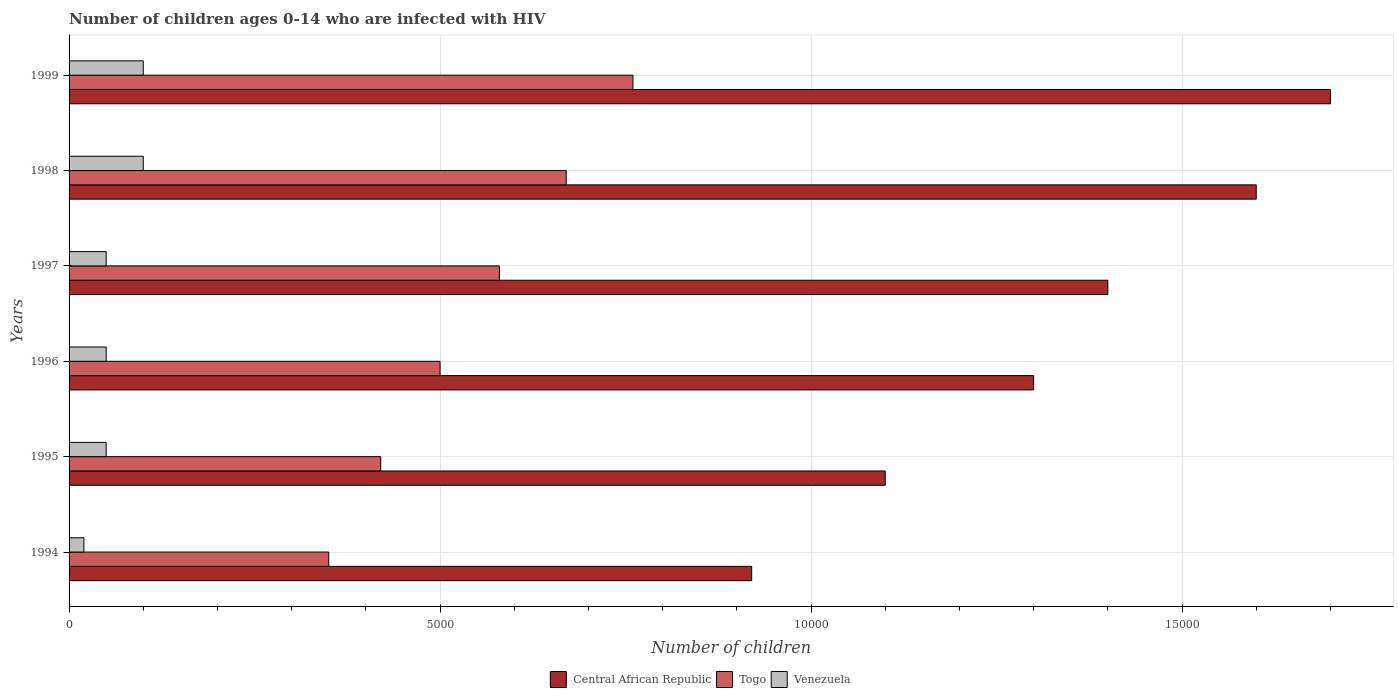Are the number of bars per tick equal to the number of legend labels?
Provide a succinct answer. Yes. How many bars are there on the 1st tick from the top?
Your response must be concise. 3. What is the label of the 1st group of bars from the top?
Keep it short and to the point. 1999. In how many cases, is the number of bars for a given year not equal to the number of legend labels?
Your response must be concise. 0. What is the number of HIV infected children in Togo in 1999?
Ensure brevity in your answer.  7600. Across all years, what is the maximum number of HIV infected children in Venezuela?
Your response must be concise. 1000. Across all years, what is the minimum number of HIV infected children in Central African Republic?
Your response must be concise. 9200. What is the total number of HIV infected children in Togo in the graph?
Ensure brevity in your answer.  3.28e+04. What is the difference between the number of HIV infected children in Togo in 1995 and that in 1996?
Ensure brevity in your answer.  -800. What is the difference between the number of HIV infected children in Central African Republic in 1996 and the number of HIV infected children in Togo in 1995?
Provide a succinct answer. 8800. What is the average number of HIV infected children in Venezuela per year?
Your response must be concise. 616.67. In the year 1996, what is the difference between the number of HIV infected children in Venezuela and number of HIV infected children in Togo?
Your answer should be compact. -4500. Is the number of HIV infected children in Central African Republic in 1994 less than that in 1999?
Offer a terse response. Yes. What is the difference between the highest and the lowest number of HIV infected children in Central African Republic?
Give a very brief answer. 7800. In how many years, is the number of HIV infected children in Togo greater than the average number of HIV infected children in Togo taken over all years?
Your response must be concise. 3. What does the 3rd bar from the top in 1997 represents?
Provide a succinct answer. Central African Republic. What does the 1st bar from the bottom in 1995 represents?
Keep it short and to the point. Central African Republic. Is it the case that in every year, the sum of the number of HIV infected children in Venezuela and number of HIV infected children in Togo is greater than the number of HIV infected children in Central African Republic?
Provide a short and direct response. No. Does the graph contain grids?
Offer a terse response. Yes. Where does the legend appear in the graph?
Offer a very short reply. Bottom center. How many legend labels are there?
Keep it short and to the point. 3. What is the title of the graph?
Keep it short and to the point. Number of children ages 0-14 who are infected with HIV. Does "Mongolia" appear as one of the legend labels in the graph?
Provide a short and direct response. No. What is the label or title of the X-axis?
Give a very brief answer. Number of children. What is the label or title of the Y-axis?
Offer a terse response. Years. What is the Number of children of Central African Republic in 1994?
Make the answer very short. 9200. What is the Number of children of Togo in 1994?
Offer a terse response. 3500. What is the Number of children of Venezuela in 1994?
Ensure brevity in your answer.  200. What is the Number of children of Central African Republic in 1995?
Give a very brief answer. 1.10e+04. What is the Number of children in Togo in 1995?
Provide a succinct answer. 4200. What is the Number of children in Venezuela in 1995?
Keep it short and to the point. 500. What is the Number of children in Central African Republic in 1996?
Keep it short and to the point. 1.30e+04. What is the Number of children of Central African Republic in 1997?
Ensure brevity in your answer.  1.40e+04. What is the Number of children of Togo in 1997?
Offer a terse response. 5800. What is the Number of children of Central African Republic in 1998?
Provide a succinct answer. 1.60e+04. What is the Number of children in Togo in 1998?
Ensure brevity in your answer.  6700. What is the Number of children of Central African Republic in 1999?
Keep it short and to the point. 1.70e+04. What is the Number of children of Togo in 1999?
Provide a short and direct response. 7600. Across all years, what is the maximum Number of children in Central African Republic?
Give a very brief answer. 1.70e+04. Across all years, what is the maximum Number of children in Togo?
Keep it short and to the point. 7600. Across all years, what is the maximum Number of children of Venezuela?
Your response must be concise. 1000. Across all years, what is the minimum Number of children in Central African Republic?
Keep it short and to the point. 9200. Across all years, what is the minimum Number of children of Togo?
Make the answer very short. 3500. Across all years, what is the minimum Number of children of Venezuela?
Offer a terse response. 200. What is the total Number of children in Central African Republic in the graph?
Your answer should be compact. 8.02e+04. What is the total Number of children in Togo in the graph?
Your response must be concise. 3.28e+04. What is the total Number of children in Venezuela in the graph?
Provide a succinct answer. 3700. What is the difference between the Number of children in Central African Republic in 1994 and that in 1995?
Your answer should be very brief. -1800. What is the difference between the Number of children in Togo in 1994 and that in 1995?
Offer a very short reply. -700. What is the difference between the Number of children in Venezuela in 1994 and that in 1995?
Make the answer very short. -300. What is the difference between the Number of children in Central African Republic in 1994 and that in 1996?
Give a very brief answer. -3800. What is the difference between the Number of children of Togo in 1994 and that in 1996?
Your answer should be very brief. -1500. What is the difference between the Number of children of Venezuela in 1994 and that in 1996?
Provide a short and direct response. -300. What is the difference between the Number of children in Central African Republic in 1994 and that in 1997?
Offer a very short reply. -4800. What is the difference between the Number of children of Togo in 1994 and that in 1997?
Offer a terse response. -2300. What is the difference between the Number of children of Venezuela in 1994 and that in 1997?
Provide a succinct answer. -300. What is the difference between the Number of children of Central African Republic in 1994 and that in 1998?
Provide a short and direct response. -6800. What is the difference between the Number of children in Togo in 1994 and that in 1998?
Your answer should be very brief. -3200. What is the difference between the Number of children in Venezuela in 1994 and that in 1998?
Make the answer very short. -800. What is the difference between the Number of children of Central African Republic in 1994 and that in 1999?
Offer a very short reply. -7800. What is the difference between the Number of children of Togo in 1994 and that in 1999?
Provide a short and direct response. -4100. What is the difference between the Number of children of Venezuela in 1994 and that in 1999?
Give a very brief answer. -800. What is the difference between the Number of children in Central African Republic in 1995 and that in 1996?
Provide a succinct answer. -2000. What is the difference between the Number of children in Togo in 1995 and that in 1996?
Provide a succinct answer. -800. What is the difference between the Number of children in Venezuela in 1995 and that in 1996?
Your answer should be compact. 0. What is the difference between the Number of children of Central African Republic in 1995 and that in 1997?
Offer a terse response. -3000. What is the difference between the Number of children of Togo in 1995 and that in 1997?
Provide a short and direct response. -1600. What is the difference between the Number of children of Central African Republic in 1995 and that in 1998?
Your response must be concise. -5000. What is the difference between the Number of children in Togo in 1995 and that in 1998?
Ensure brevity in your answer.  -2500. What is the difference between the Number of children in Venezuela in 1995 and that in 1998?
Ensure brevity in your answer.  -500. What is the difference between the Number of children in Central African Republic in 1995 and that in 1999?
Make the answer very short. -6000. What is the difference between the Number of children in Togo in 1995 and that in 1999?
Offer a very short reply. -3400. What is the difference between the Number of children in Venezuela in 1995 and that in 1999?
Ensure brevity in your answer.  -500. What is the difference between the Number of children of Central African Republic in 1996 and that in 1997?
Keep it short and to the point. -1000. What is the difference between the Number of children of Togo in 1996 and that in 1997?
Ensure brevity in your answer.  -800. What is the difference between the Number of children of Venezuela in 1996 and that in 1997?
Offer a terse response. 0. What is the difference between the Number of children in Central African Republic in 1996 and that in 1998?
Your answer should be very brief. -3000. What is the difference between the Number of children in Togo in 1996 and that in 1998?
Offer a very short reply. -1700. What is the difference between the Number of children in Venezuela in 1996 and that in 1998?
Provide a succinct answer. -500. What is the difference between the Number of children of Central African Republic in 1996 and that in 1999?
Provide a short and direct response. -4000. What is the difference between the Number of children in Togo in 1996 and that in 1999?
Your answer should be very brief. -2600. What is the difference between the Number of children of Venezuela in 1996 and that in 1999?
Make the answer very short. -500. What is the difference between the Number of children of Central African Republic in 1997 and that in 1998?
Offer a very short reply. -2000. What is the difference between the Number of children in Togo in 1997 and that in 1998?
Ensure brevity in your answer.  -900. What is the difference between the Number of children of Venezuela in 1997 and that in 1998?
Keep it short and to the point. -500. What is the difference between the Number of children in Central African Republic in 1997 and that in 1999?
Give a very brief answer. -3000. What is the difference between the Number of children of Togo in 1997 and that in 1999?
Your answer should be very brief. -1800. What is the difference between the Number of children of Venezuela in 1997 and that in 1999?
Your answer should be very brief. -500. What is the difference between the Number of children in Central African Republic in 1998 and that in 1999?
Provide a succinct answer. -1000. What is the difference between the Number of children of Togo in 1998 and that in 1999?
Your answer should be very brief. -900. What is the difference between the Number of children of Central African Republic in 1994 and the Number of children of Venezuela in 1995?
Provide a short and direct response. 8700. What is the difference between the Number of children in Togo in 1994 and the Number of children in Venezuela in 1995?
Offer a terse response. 3000. What is the difference between the Number of children in Central African Republic in 1994 and the Number of children in Togo in 1996?
Offer a terse response. 4200. What is the difference between the Number of children of Central African Republic in 1994 and the Number of children of Venezuela in 1996?
Make the answer very short. 8700. What is the difference between the Number of children in Togo in 1994 and the Number of children in Venezuela in 1996?
Your answer should be compact. 3000. What is the difference between the Number of children of Central African Republic in 1994 and the Number of children of Togo in 1997?
Your response must be concise. 3400. What is the difference between the Number of children of Central African Republic in 1994 and the Number of children of Venezuela in 1997?
Your response must be concise. 8700. What is the difference between the Number of children in Togo in 1994 and the Number of children in Venezuela in 1997?
Your response must be concise. 3000. What is the difference between the Number of children of Central African Republic in 1994 and the Number of children of Togo in 1998?
Provide a short and direct response. 2500. What is the difference between the Number of children of Central African Republic in 1994 and the Number of children of Venezuela in 1998?
Your answer should be very brief. 8200. What is the difference between the Number of children in Togo in 1994 and the Number of children in Venezuela in 1998?
Your response must be concise. 2500. What is the difference between the Number of children in Central African Republic in 1994 and the Number of children in Togo in 1999?
Make the answer very short. 1600. What is the difference between the Number of children of Central African Republic in 1994 and the Number of children of Venezuela in 1999?
Your response must be concise. 8200. What is the difference between the Number of children in Togo in 1994 and the Number of children in Venezuela in 1999?
Offer a very short reply. 2500. What is the difference between the Number of children in Central African Republic in 1995 and the Number of children in Togo in 1996?
Provide a short and direct response. 6000. What is the difference between the Number of children in Central African Republic in 1995 and the Number of children in Venezuela in 1996?
Your response must be concise. 1.05e+04. What is the difference between the Number of children in Togo in 1995 and the Number of children in Venezuela in 1996?
Your answer should be very brief. 3700. What is the difference between the Number of children in Central African Republic in 1995 and the Number of children in Togo in 1997?
Your answer should be compact. 5200. What is the difference between the Number of children in Central African Republic in 1995 and the Number of children in Venezuela in 1997?
Your answer should be very brief. 1.05e+04. What is the difference between the Number of children in Togo in 1995 and the Number of children in Venezuela in 1997?
Offer a very short reply. 3700. What is the difference between the Number of children of Central African Republic in 1995 and the Number of children of Togo in 1998?
Your answer should be compact. 4300. What is the difference between the Number of children of Togo in 1995 and the Number of children of Venezuela in 1998?
Your answer should be compact. 3200. What is the difference between the Number of children of Central African Republic in 1995 and the Number of children of Togo in 1999?
Offer a terse response. 3400. What is the difference between the Number of children in Central African Republic in 1995 and the Number of children in Venezuela in 1999?
Give a very brief answer. 10000. What is the difference between the Number of children in Togo in 1995 and the Number of children in Venezuela in 1999?
Provide a short and direct response. 3200. What is the difference between the Number of children of Central African Republic in 1996 and the Number of children of Togo in 1997?
Your answer should be very brief. 7200. What is the difference between the Number of children in Central African Republic in 1996 and the Number of children in Venezuela in 1997?
Keep it short and to the point. 1.25e+04. What is the difference between the Number of children in Togo in 1996 and the Number of children in Venezuela in 1997?
Offer a very short reply. 4500. What is the difference between the Number of children of Central African Republic in 1996 and the Number of children of Togo in 1998?
Your answer should be compact. 6300. What is the difference between the Number of children of Central African Republic in 1996 and the Number of children of Venezuela in 1998?
Give a very brief answer. 1.20e+04. What is the difference between the Number of children in Togo in 1996 and the Number of children in Venezuela in 1998?
Give a very brief answer. 4000. What is the difference between the Number of children in Central African Republic in 1996 and the Number of children in Togo in 1999?
Provide a succinct answer. 5400. What is the difference between the Number of children of Central African Republic in 1996 and the Number of children of Venezuela in 1999?
Make the answer very short. 1.20e+04. What is the difference between the Number of children of Togo in 1996 and the Number of children of Venezuela in 1999?
Keep it short and to the point. 4000. What is the difference between the Number of children of Central African Republic in 1997 and the Number of children of Togo in 1998?
Make the answer very short. 7300. What is the difference between the Number of children of Central African Republic in 1997 and the Number of children of Venezuela in 1998?
Make the answer very short. 1.30e+04. What is the difference between the Number of children in Togo in 1997 and the Number of children in Venezuela in 1998?
Your response must be concise. 4800. What is the difference between the Number of children in Central African Republic in 1997 and the Number of children in Togo in 1999?
Make the answer very short. 6400. What is the difference between the Number of children of Central African Republic in 1997 and the Number of children of Venezuela in 1999?
Offer a very short reply. 1.30e+04. What is the difference between the Number of children in Togo in 1997 and the Number of children in Venezuela in 1999?
Your answer should be compact. 4800. What is the difference between the Number of children in Central African Republic in 1998 and the Number of children in Togo in 1999?
Your answer should be very brief. 8400. What is the difference between the Number of children in Central African Republic in 1998 and the Number of children in Venezuela in 1999?
Your answer should be very brief. 1.50e+04. What is the difference between the Number of children in Togo in 1998 and the Number of children in Venezuela in 1999?
Ensure brevity in your answer.  5700. What is the average Number of children of Central African Republic per year?
Provide a short and direct response. 1.34e+04. What is the average Number of children of Togo per year?
Give a very brief answer. 5466.67. What is the average Number of children in Venezuela per year?
Keep it short and to the point. 616.67. In the year 1994, what is the difference between the Number of children in Central African Republic and Number of children in Togo?
Ensure brevity in your answer.  5700. In the year 1994, what is the difference between the Number of children of Central African Republic and Number of children of Venezuela?
Your answer should be very brief. 9000. In the year 1994, what is the difference between the Number of children of Togo and Number of children of Venezuela?
Make the answer very short. 3300. In the year 1995, what is the difference between the Number of children of Central African Republic and Number of children of Togo?
Ensure brevity in your answer.  6800. In the year 1995, what is the difference between the Number of children in Central African Republic and Number of children in Venezuela?
Provide a succinct answer. 1.05e+04. In the year 1995, what is the difference between the Number of children of Togo and Number of children of Venezuela?
Ensure brevity in your answer.  3700. In the year 1996, what is the difference between the Number of children in Central African Republic and Number of children in Togo?
Offer a terse response. 8000. In the year 1996, what is the difference between the Number of children in Central African Republic and Number of children in Venezuela?
Provide a short and direct response. 1.25e+04. In the year 1996, what is the difference between the Number of children in Togo and Number of children in Venezuela?
Offer a terse response. 4500. In the year 1997, what is the difference between the Number of children in Central African Republic and Number of children in Togo?
Offer a very short reply. 8200. In the year 1997, what is the difference between the Number of children in Central African Republic and Number of children in Venezuela?
Provide a succinct answer. 1.35e+04. In the year 1997, what is the difference between the Number of children in Togo and Number of children in Venezuela?
Provide a succinct answer. 5300. In the year 1998, what is the difference between the Number of children of Central African Republic and Number of children of Togo?
Provide a short and direct response. 9300. In the year 1998, what is the difference between the Number of children of Central African Republic and Number of children of Venezuela?
Your response must be concise. 1.50e+04. In the year 1998, what is the difference between the Number of children in Togo and Number of children in Venezuela?
Offer a very short reply. 5700. In the year 1999, what is the difference between the Number of children of Central African Republic and Number of children of Togo?
Your answer should be compact. 9400. In the year 1999, what is the difference between the Number of children of Central African Republic and Number of children of Venezuela?
Provide a short and direct response. 1.60e+04. In the year 1999, what is the difference between the Number of children of Togo and Number of children of Venezuela?
Your answer should be compact. 6600. What is the ratio of the Number of children of Central African Republic in 1994 to that in 1995?
Provide a short and direct response. 0.84. What is the ratio of the Number of children in Central African Republic in 1994 to that in 1996?
Your response must be concise. 0.71. What is the ratio of the Number of children in Togo in 1994 to that in 1996?
Your response must be concise. 0.7. What is the ratio of the Number of children in Venezuela in 1994 to that in 1996?
Offer a terse response. 0.4. What is the ratio of the Number of children in Central African Republic in 1994 to that in 1997?
Provide a short and direct response. 0.66. What is the ratio of the Number of children of Togo in 1994 to that in 1997?
Provide a succinct answer. 0.6. What is the ratio of the Number of children in Venezuela in 1994 to that in 1997?
Your response must be concise. 0.4. What is the ratio of the Number of children in Central African Republic in 1994 to that in 1998?
Ensure brevity in your answer.  0.57. What is the ratio of the Number of children of Togo in 1994 to that in 1998?
Provide a succinct answer. 0.52. What is the ratio of the Number of children in Venezuela in 1994 to that in 1998?
Keep it short and to the point. 0.2. What is the ratio of the Number of children of Central African Republic in 1994 to that in 1999?
Your answer should be compact. 0.54. What is the ratio of the Number of children of Togo in 1994 to that in 1999?
Offer a very short reply. 0.46. What is the ratio of the Number of children in Venezuela in 1994 to that in 1999?
Offer a terse response. 0.2. What is the ratio of the Number of children of Central African Republic in 1995 to that in 1996?
Offer a terse response. 0.85. What is the ratio of the Number of children of Togo in 1995 to that in 1996?
Ensure brevity in your answer.  0.84. What is the ratio of the Number of children in Central African Republic in 1995 to that in 1997?
Your response must be concise. 0.79. What is the ratio of the Number of children in Togo in 1995 to that in 1997?
Your response must be concise. 0.72. What is the ratio of the Number of children of Central African Republic in 1995 to that in 1998?
Your response must be concise. 0.69. What is the ratio of the Number of children of Togo in 1995 to that in 1998?
Make the answer very short. 0.63. What is the ratio of the Number of children in Venezuela in 1995 to that in 1998?
Your answer should be compact. 0.5. What is the ratio of the Number of children of Central African Republic in 1995 to that in 1999?
Give a very brief answer. 0.65. What is the ratio of the Number of children in Togo in 1995 to that in 1999?
Offer a very short reply. 0.55. What is the ratio of the Number of children of Venezuela in 1995 to that in 1999?
Your answer should be compact. 0.5. What is the ratio of the Number of children in Central African Republic in 1996 to that in 1997?
Provide a succinct answer. 0.93. What is the ratio of the Number of children of Togo in 1996 to that in 1997?
Ensure brevity in your answer.  0.86. What is the ratio of the Number of children in Central African Republic in 1996 to that in 1998?
Provide a short and direct response. 0.81. What is the ratio of the Number of children in Togo in 1996 to that in 1998?
Keep it short and to the point. 0.75. What is the ratio of the Number of children of Central African Republic in 1996 to that in 1999?
Your answer should be compact. 0.76. What is the ratio of the Number of children of Togo in 1996 to that in 1999?
Provide a short and direct response. 0.66. What is the ratio of the Number of children in Venezuela in 1996 to that in 1999?
Provide a short and direct response. 0.5. What is the ratio of the Number of children of Central African Republic in 1997 to that in 1998?
Provide a succinct answer. 0.88. What is the ratio of the Number of children of Togo in 1997 to that in 1998?
Provide a short and direct response. 0.87. What is the ratio of the Number of children of Central African Republic in 1997 to that in 1999?
Give a very brief answer. 0.82. What is the ratio of the Number of children in Togo in 1997 to that in 1999?
Provide a short and direct response. 0.76. What is the ratio of the Number of children in Venezuela in 1997 to that in 1999?
Your response must be concise. 0.5. What is the ratio of the Number of children of Central African Republic in 1998 to that in 1999?
Provide a succinct answer. 0.94. What is the ratio of the Number of children in Togo in 1998 to that in 1999?
Offer a terse response. 0.88. What is the difference between the highest and the second highest Number of children of Central African Republic?
Provide a succinct answer. 1000. What is the difference between the highest and the second highest Number of children in Togo?
Your answer should be compact. 900. What is the difference between the highest and the second highest Number of children in Venezuela?
Make the answer very short. 0. What is the difference between the highest and the lowest Number of children of Central African Republic?
Your answer should be compact. 7800. What is the difference between the highest and the lowest Number of children in Togo?
Provide a succinct answer. 4100. What is the difference between the highest and the lowest Number of children in Venezuela?
Your response must be concise. 800. 